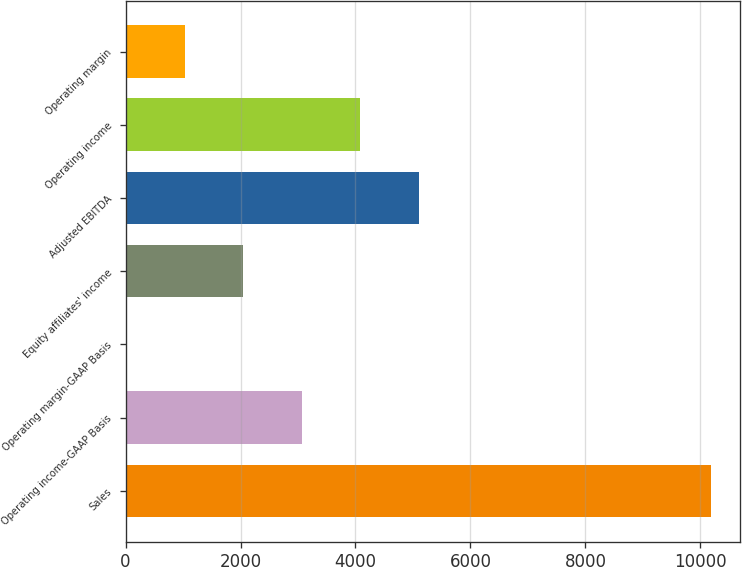<chart> <loc_0><loc_0><loc_500><loc_500><bar_chart><fcel>Sales<fcel>Operating income-GAAP Basis<fcel>Operating margin-GAAP Basis<fcel>Equity affiliates' income<fcel>Adjusted EBITDA<fcel>Operating income<fcel>Operating margin<nl><fcel>10180.4<fcel>3063.22<fcel>13<fcel>2046.48<fcel>5096.7<fcel>4079.96<fcel>1029.74<nl></chart> 